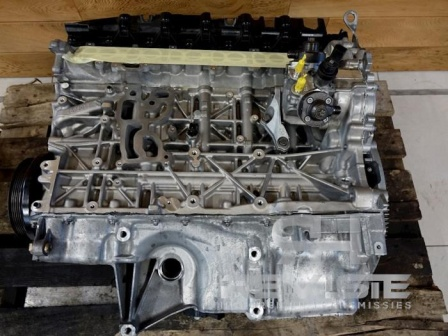Can you elaborate on the elements of the picture provided? The image features a detailed view of a car engine block. This core component, made of silver-colored metal, is pivotal in the vehicle's internal combustion process. The metal framework showcases the engine block, which houses the cylinders where fuel ignition takes place. 

Atop the engine block, a black plastic cover is visible, likely designed to protect the engine's inner components. To the side, a prominent yellow plastic cap is observed, probably serving as a reservoir cap for essential engine fluids. 

Additionally, the engine block is intertwined with several metal pipes and tubes. These elements are crucial for the engine's functioning, likely forming parts of the cooling system or fuel and air intake mechanisms. 

Interestingly, this engine block is not installed in a car; instead, it rests on a wooden pallet. The wooden pallet, with its distinctive slatted design and brown hue, contrasts sharply against the engine’s metal surface. 

The background setting suggests a workshop or a garage environment, indicated by the presence of a rough, gray concrete floor. Such floors are typical in these places, valued for their durability and resistance to oil and other automotive fluids.

In essence, the image captures a stationary moment for this engine block, which might be awaiting installation into a vehicle or has been removed for repair or refurbishment. 